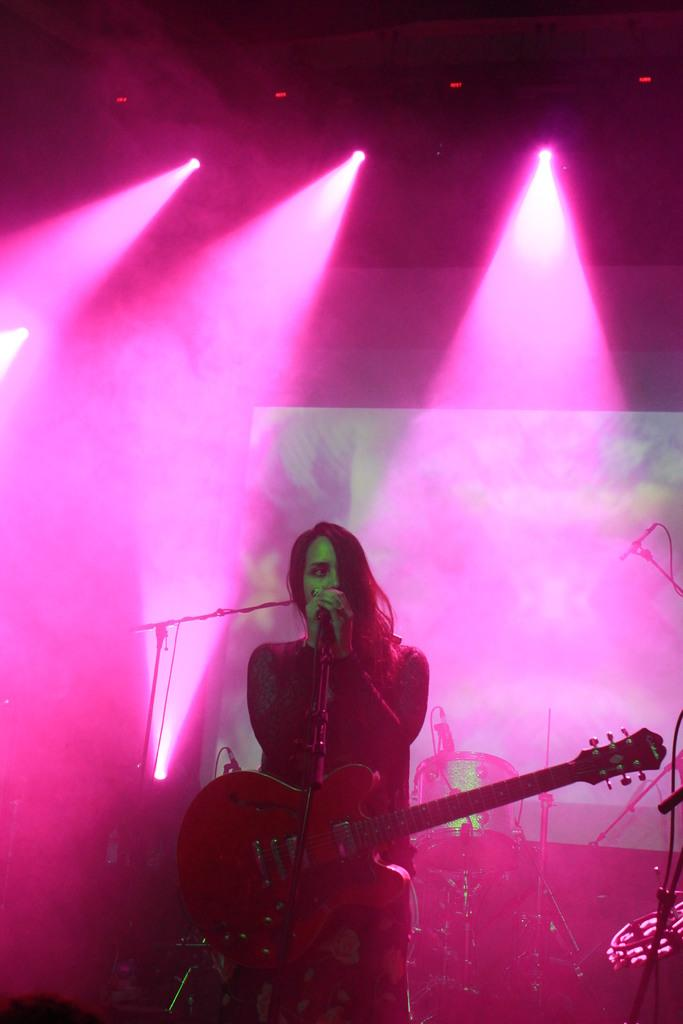Who is the main subject in the image? There is a woman in the image. What is the woman holding in the image? The woman is carrying a guitar. What is the woman doing in front of the microphone? The woman is singing in front of a microphone. What other musical instrument is present in the image? There are drums behind the woman. What color are the lights visible in the background? Pink lights are visible in the background. What type of nail is the woman using to play the guitar in the image? There is no nail visible in the image, and the woman is not using a nail to play the guitar. 